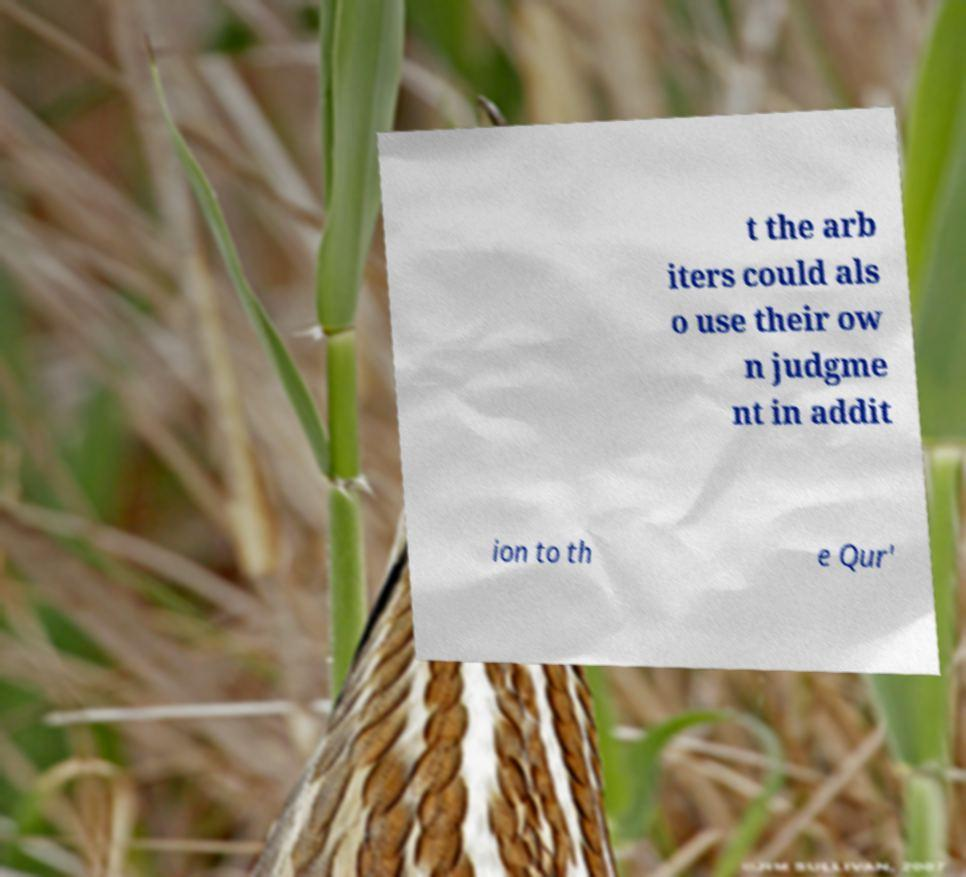There's text embedded in this image that I need extracted. Can you transcribe it verbatim? t the arb iters could als o use their ow n judgme nt in addit ion to th e Qur' 